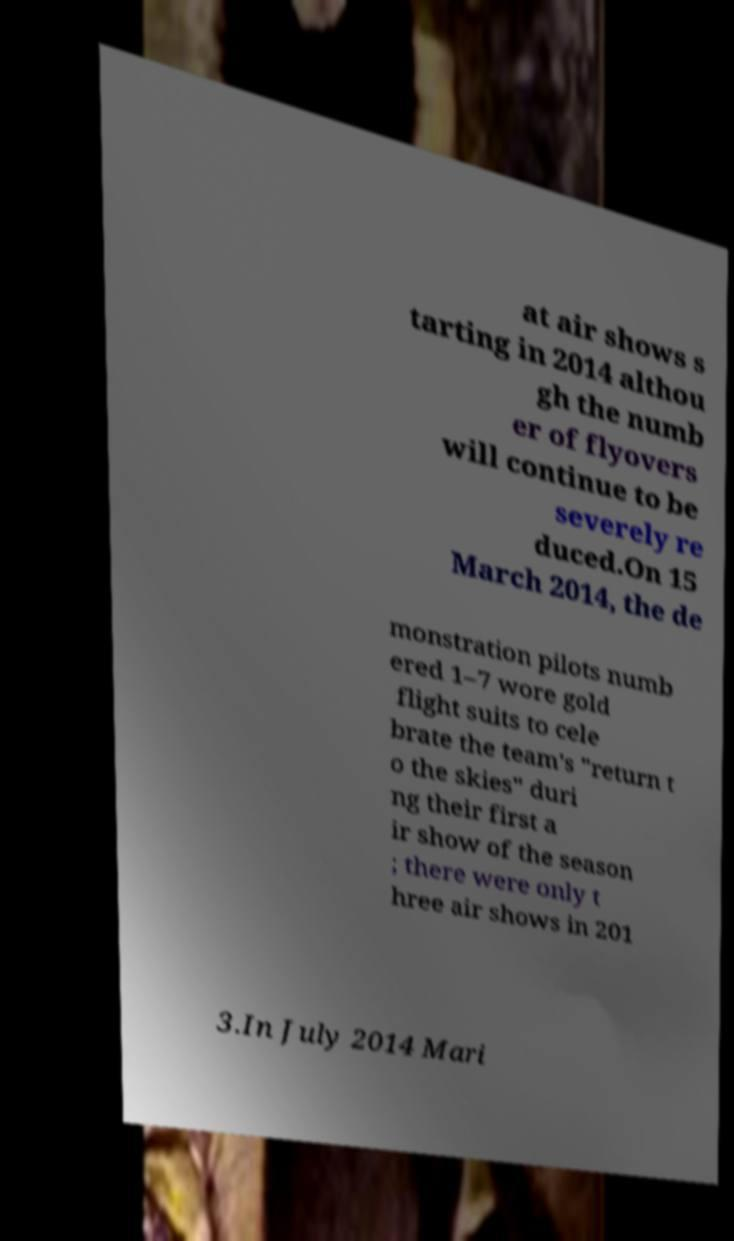Can you accurately transcribe the text from the provided image for me? at air shows s tarting in 2014 althou gh the numb er of flyovers will continue to be severely re duced.On 15 March 2014, the de monstration pilots numb ered 1–7 wore gold flight suits to cele brate the team's "return t o the skies" duri ng their first a ir show of the season ; there were only t hree air shows in 201 3.In July 2014 Mari 